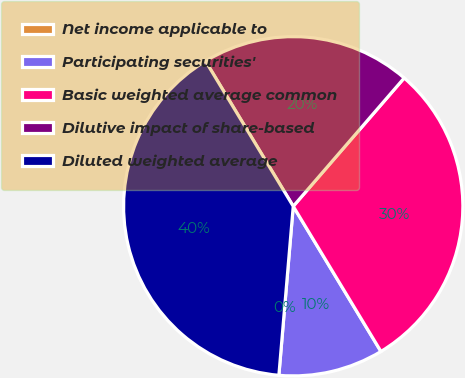Convert chart to OTSL. <chart><loc_0><loc_0><loc_500><loc_500><pie_chart><fcel>Net income applicable to<fcel>Participating securities'<fcel>Basic weighted average common<fcel>Dilutive impact of share-based<fcel>Diluted weighted average<nl><fcel>0.0%<fcel>10.0%<fcel>30.0%<fcel>20.0%<fcel>40.0%<nl></chart> 